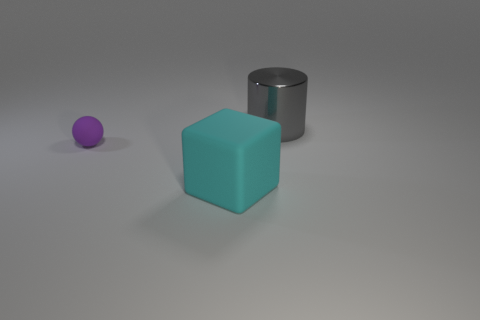Add 3 cubes. How many objects exist? 6 Subtract all cubes. How many objects are left? 2 Subtract 0 blue cylinders. How many objects are left? 3 Subtract all yellow cylinders. Subtract all brown balls. How many cylinders are left? 1 Subtract all tiny purple rubber spheres. Subtract all big matte objects. How many objects are left? 1 Add 2 small balls. How many small balls are left? 3 Add 3 large cyan rubber things. How many large cyan rubber things exist? 4 